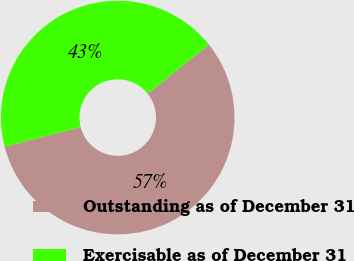Convert chart to OTSL. <chart><loc_0><loc_0><loc_500><loc_500><pie_chart><fcel>Outstanding as of December 31<fcel>Exercisable as of December 31<nl><fcel>56.72%<fcel>43.28%<nl></chart> 